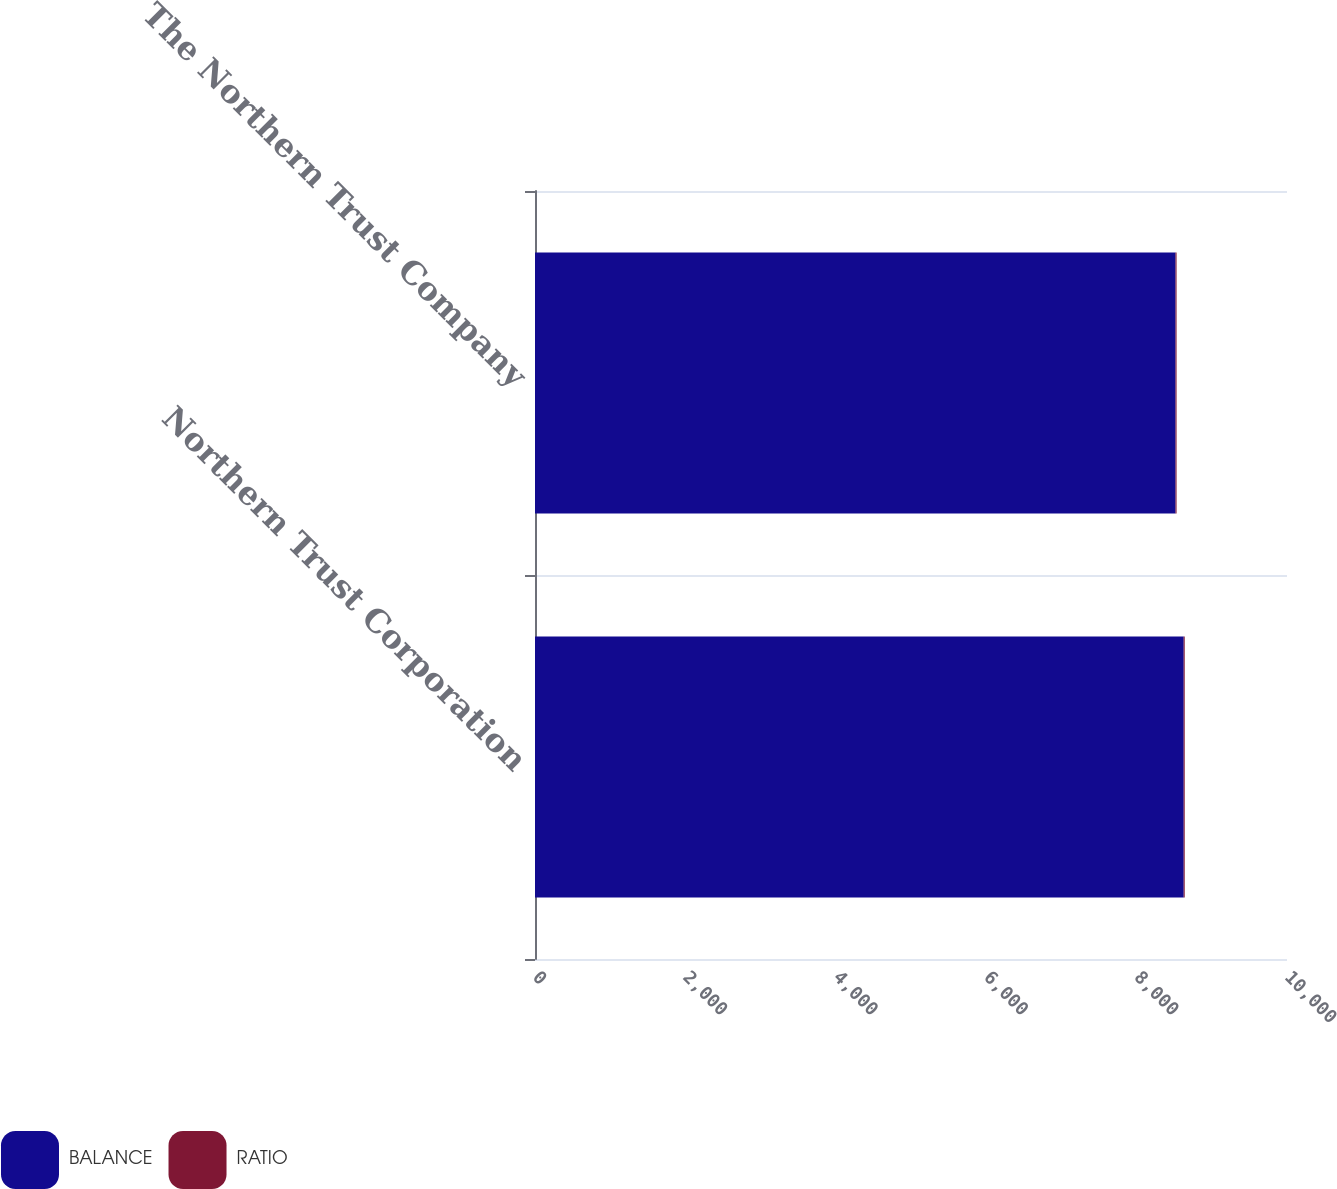<chart> <loc_0><loc_0><loc_500><loc_500><stacked_bar_chart><ecel><fcel>Northern Trust Corporation<fcel>The Northern Trust Company<nl><fcel>BALANCE<fcel>8626.3<fcel>8517.8<nl><fcel>RATIO<fcel>13.5<fcel>13.7<nl></chart> 